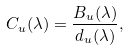Convert formula to latex. <formula><loc_0><loc_0><loc_500><loc_500>C _ { u } ( \lambda ) = \frac { B _ { u } ( \lambda ) } { d _ { u } ( \lambda ) } ,</formula> 